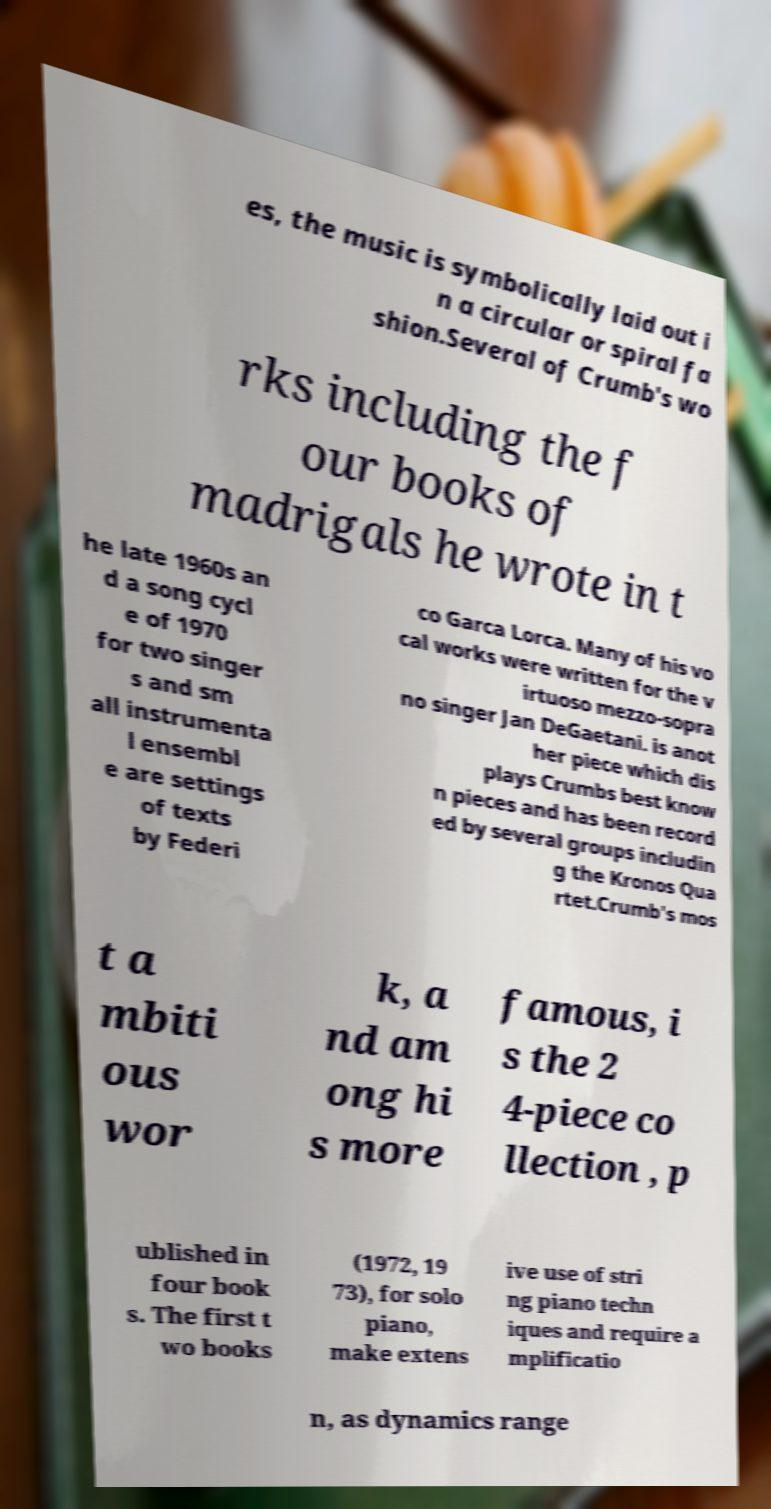Could you extract and type out the text from this image? es, the music is symbolically laid out i n a circular or spiral fa shion.Several of Crumb's wo rks including the f our books of madrigals he wrote in t he late 1960s an d a song cycl e of 1970 for two singer s and sm all instrumenta l ensembl e are settings of texts by Federi co Garca Lorca. Many of his vo cal works were written for the v irtuoso mezzo-sopra no singer Jan DeGaetani. is anot her piece which dis plays Crumbs best know n pieces and has been record ed by several groups includin g the Kronos Qua rtet.Crumb's mos t a mbiti ous wor k, a nd am ong hi s more famous, i s the 2 4-piece co llection , p ublished in four book s. The first t wo books (1972, 19 73), for solo piano, make extens ive use of stri ng piano techn iques and require a mplificatio n, as dynamics range 